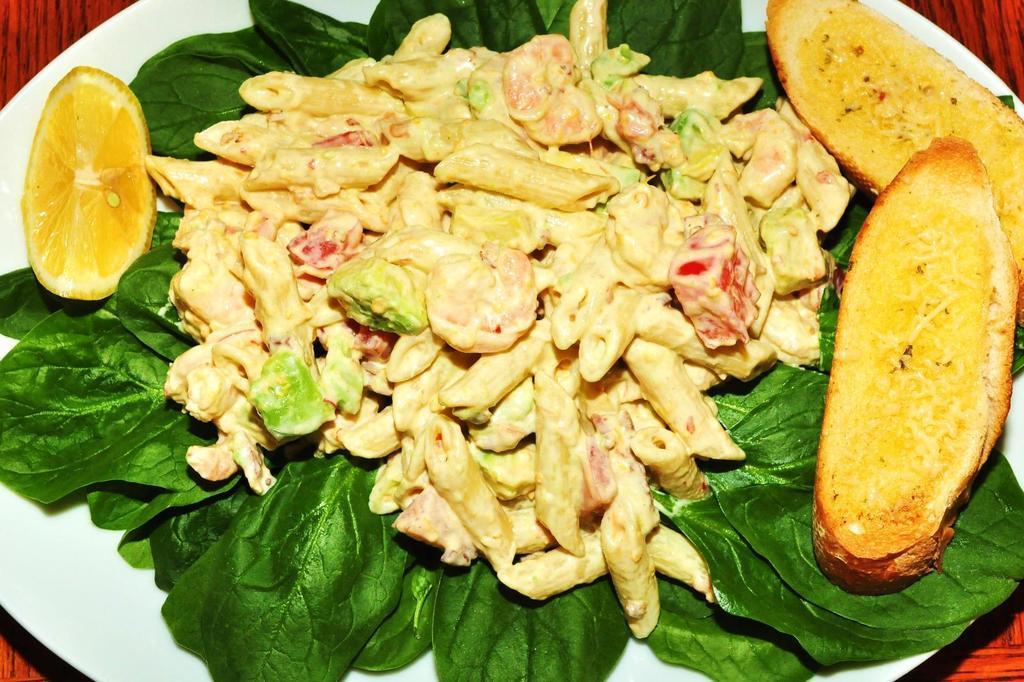Please provide a concise description of this image. In this image we can see the plate of food items and also leaves and the plate is placed on the wooden surface. 